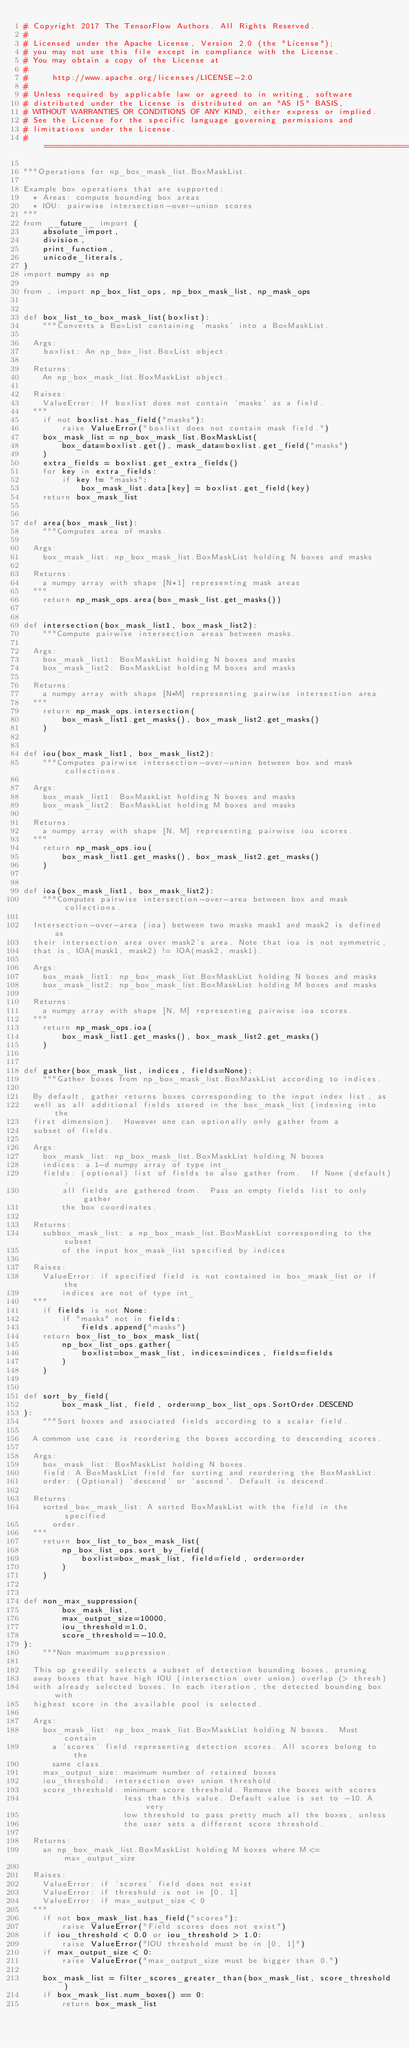<code> <loc_0><loc_0><loc_500><loc_500><_Python_># Copyright 2017 The TensorFlow Authors. All Rights Reserved.
#
# Licensed under the Apache License, Version 2.0 (the "License");
# you may not use this file except in compliance with the License.
# You may obtain a copy of the License at
#
#     http://www.apache.org/licenses/LICENSE-2.0
#
# Unless required by applicable law or agreed to in writing, software
# distributed under the License is distributed on an "AS IS" BASIS,
# WITHOUT WARRANTIES OR CONDITIONS OF ANY KIND, either express or implied.
# See the License for the specific language governing permissions and
# limitations under the License.
# ==============================================================================

"""Operations for np_box_mask_list.BoxMaskList.

Example box operations that are supported:
  * Areas: compute bounding box areas
  * IOU: pairwise intersection-over-union scores
"""
from __future__ import (
    absolute_import,
    division,
    print_function,
    unicode_literals,
)
import numpy as np

from . import np_box_list_ops, np_box_mask_list, np_mask_ops


def box_list_to_box_mask_list(boxlist):
    """Converts a BoxList containing 'masks' into a BoxMaskList.

  Args:
    boxlist: An np_box_list.BoxList object.

  Returns:
    An np_box_mask_list.BoxMaskList object.

  Raises:
    ValueError: If boxlist does not contain `masks` as a field.
  """
    if not boxlist.has_field("masks"):
        raise ValueError("boxlist does not contain mask field.")
    box_mask_list = np_box_mask_list.BoxMaskList(
        box_data=boxlist.get(), mask_data=boxlist.get_field("masks")
    )
    extra_fields = boxlist.get_extra_fields()
    for key in extra_fields:
        if key != "masks":
            box_mask_list.data[key] = boxlist.get_field(key)
    return box_mask_list


def area(box_mask_list):
    """Computes area of masks.

  Args:
    box_mask_list: np_box_mask_list.BoxMaskList holding N boxes and masks

  Returns:
    a numpy array with shape [N*1] representing mask areas
  """
    return np_mask_ops.area(box_mask_list.get_masks())


def intersection(box_mask_list1, box_mask_list2):
    """Compute pairwise intersection areas between masks.

  Args:
    box_mask_list1: BoxMaskList holding N boxes and masks
    box_mask_list2: BoxMaskList holding M boxes and masks

  Returns:
    a numpy array with shape [N*M] representing pairwise intersection area
  """
    return np_mask_ops.intersection(
        box_mask_list1.get_masks(), box_mask_list2.get_masks()
    )


def iou(box_mask_list1, box_mask_list2):
    """Computes pairwise intersection-over-union between box and mask collections.

  Args:
    box_mask_list1: BoxMaskList holding N boxes and masks
    box_mask_list2: BoxMaskList holding M boxes and masks

  Returns:
    a numpy array with shape [N, M] representing pairwise iou scores.
  """
    return np_mask_ops.iou(
        box_mask_list1.get_masks(), box_mask_list2.get_masks()
    )


def ioa(box_mask_list1, box_mask_list2):
    """Computes pairwise intersection-over-area between box and mask collections.

  Intersection-over-area (ioa) between two masks mask1 and mask2 is defined as
  their intersection area over mask2's area. Note that ioa is not symmetric,
  that is, IOA(mask1, mask2) != IOA(mask2, mask1).

  Args:
    box_mask_list1: np_box_mask_list.BoxMaskList holding N boxes and masks
    box_mask_list2: np_box_mask_list.BoxMaskList holding M boxes and masks

  Returns:
    a numpy array with shape [N, M] representing pairwise ioa scores.
  """
    return np_mask_ops.ioa(
        box_mask_list1.get_masks(), box_mask_list2.get_masks()
    )


def gather(box_mask_list, indices, fields=None):
    """Gather boxes from np_box_mask_list.BoxMaskList according to indices.

  By default, gather returns boxes corresponding to the input index list, as
  well as all additional fields stored in the box_mask_list (indexing into the
  first dimension).  However one can optionally only gather from a
  subset of fields.

  Args:
    box_mask_list: np_box_mask_list.BoxMaskList holding N boxes
    indices: a 1-d numpy array of type int_
    fields: (optional) list of fields to also gather from.  If None (default),
        all fields are gathered from.  Pass an empty fields list to only gather
        the box coordinates.

  Returns:
    subbox_mask_list: a np_box_mask_list.BoxMaskList corresponding to the subset
        of the input box_mask_list specified by indices

  Raises:
    ValueError: if specified field is not contained in box_mask_list or if the
        indices are not of type int_
  """
    if fields is not None:
        if "masks" not in fields:
            fields.append("masks")
    return box_list_to_box_mask_list(
        np_box_list_ops.gather(
            boxlist=box_mask_list, indices=indices, fields=fields
        )
    )


def sort_by_field(
        box_mask_list, field, order=np_box_list_ops.SortOrder.DESCEND
):
    """Sort boxes and associated fields according to a scalar field.

  A common use case is reordering the boxes according to descending scores.

  Args:
    box_mask_list: BoxMaskList holding N boxes.
    field: A BoxMaskList field for sorting and reordering the BoxMaskList.
    order: (Optional) 'descend' or 'ascend'. Default is descend.

  Returns:
    sorted_box_mask_list: A sorted BoxMaskList with the field in the specified
      order.
  """
    return box_list_to_box_mask_list(
        np_box_list_ops.sort_by_field(
            boxlist=box_mask_list, field=field, order=order
        )
    )


def non_max_suppression(
        box_mask_list,
        max_output_size=10000,
        iou_threshold=1.0,
        score_threshold=-10.0,
):
    """Non maximum suppression.

  This op greedily selects a subset of detection bounding boxes, pruning
  away boxes that have high IOU (intersection over union) overlap (> thresh)
  with already selected boxes. In each iteration, the detected bounding box with
  highest score in the available pool is selected.

  Args:
    box_mask_list: np_box_mask_list.BoxMaskList holding N boxes.  Must contain
      a 'scores' field representing detection scores. All scores belong to the
      same class.
    max_output_size: maximum number of retained boxes
    iou_threshold: intersection over union threshold.
    score_threshold: minimum score threshold. Remove the boxes with scores
                     less than this value. Default value is set to -10. A very
                     low threshold to pass pretty much all the boxes, unless
                     the user sets a different score threshold.

  Returns:
    an np_box_mask_list.BoxMaskList holding M boxes where M <= max_output_size

  Raises:
    ValueError: if 'scores' field does not exist
    ValueError: if threshold is not in [0, 1]
    ValueError: if max_output_size < 0
  """
    if not box_mask_list.has_field("scores"):
        raise ValueError("Field scores does not exist")
    if iou_threshold < 0.0 or iou_threshold > 1.0:
        raise ValueError("IOU threshold must be in [0, 1]")
    if max_output_size < 0:
        raise ValueError("max_output_size must be bigger than 0.")

    box_mask_list = filter_scores_greater_than(box_mask_list, score_threshold)
    if box_mask_list.num_boxes() == 0:
        return box_mask_list
</code> 